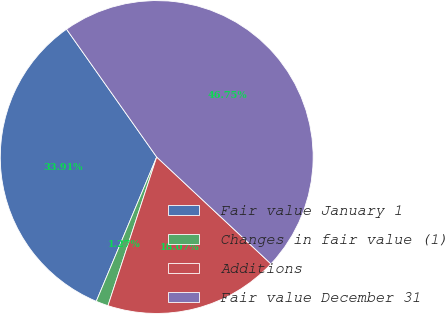<chart> <loc_0><loc_0><loc_500><loc_500><pie_chart><fcel>Fair value January 1<fcel>Changes in fair value (1)<fcel>Additions<fcel>Fair value December 31<nl><fcel>33.91%<fcel>1.27%<fcel>18.07%<fcel>46.75%<nl></chart> 